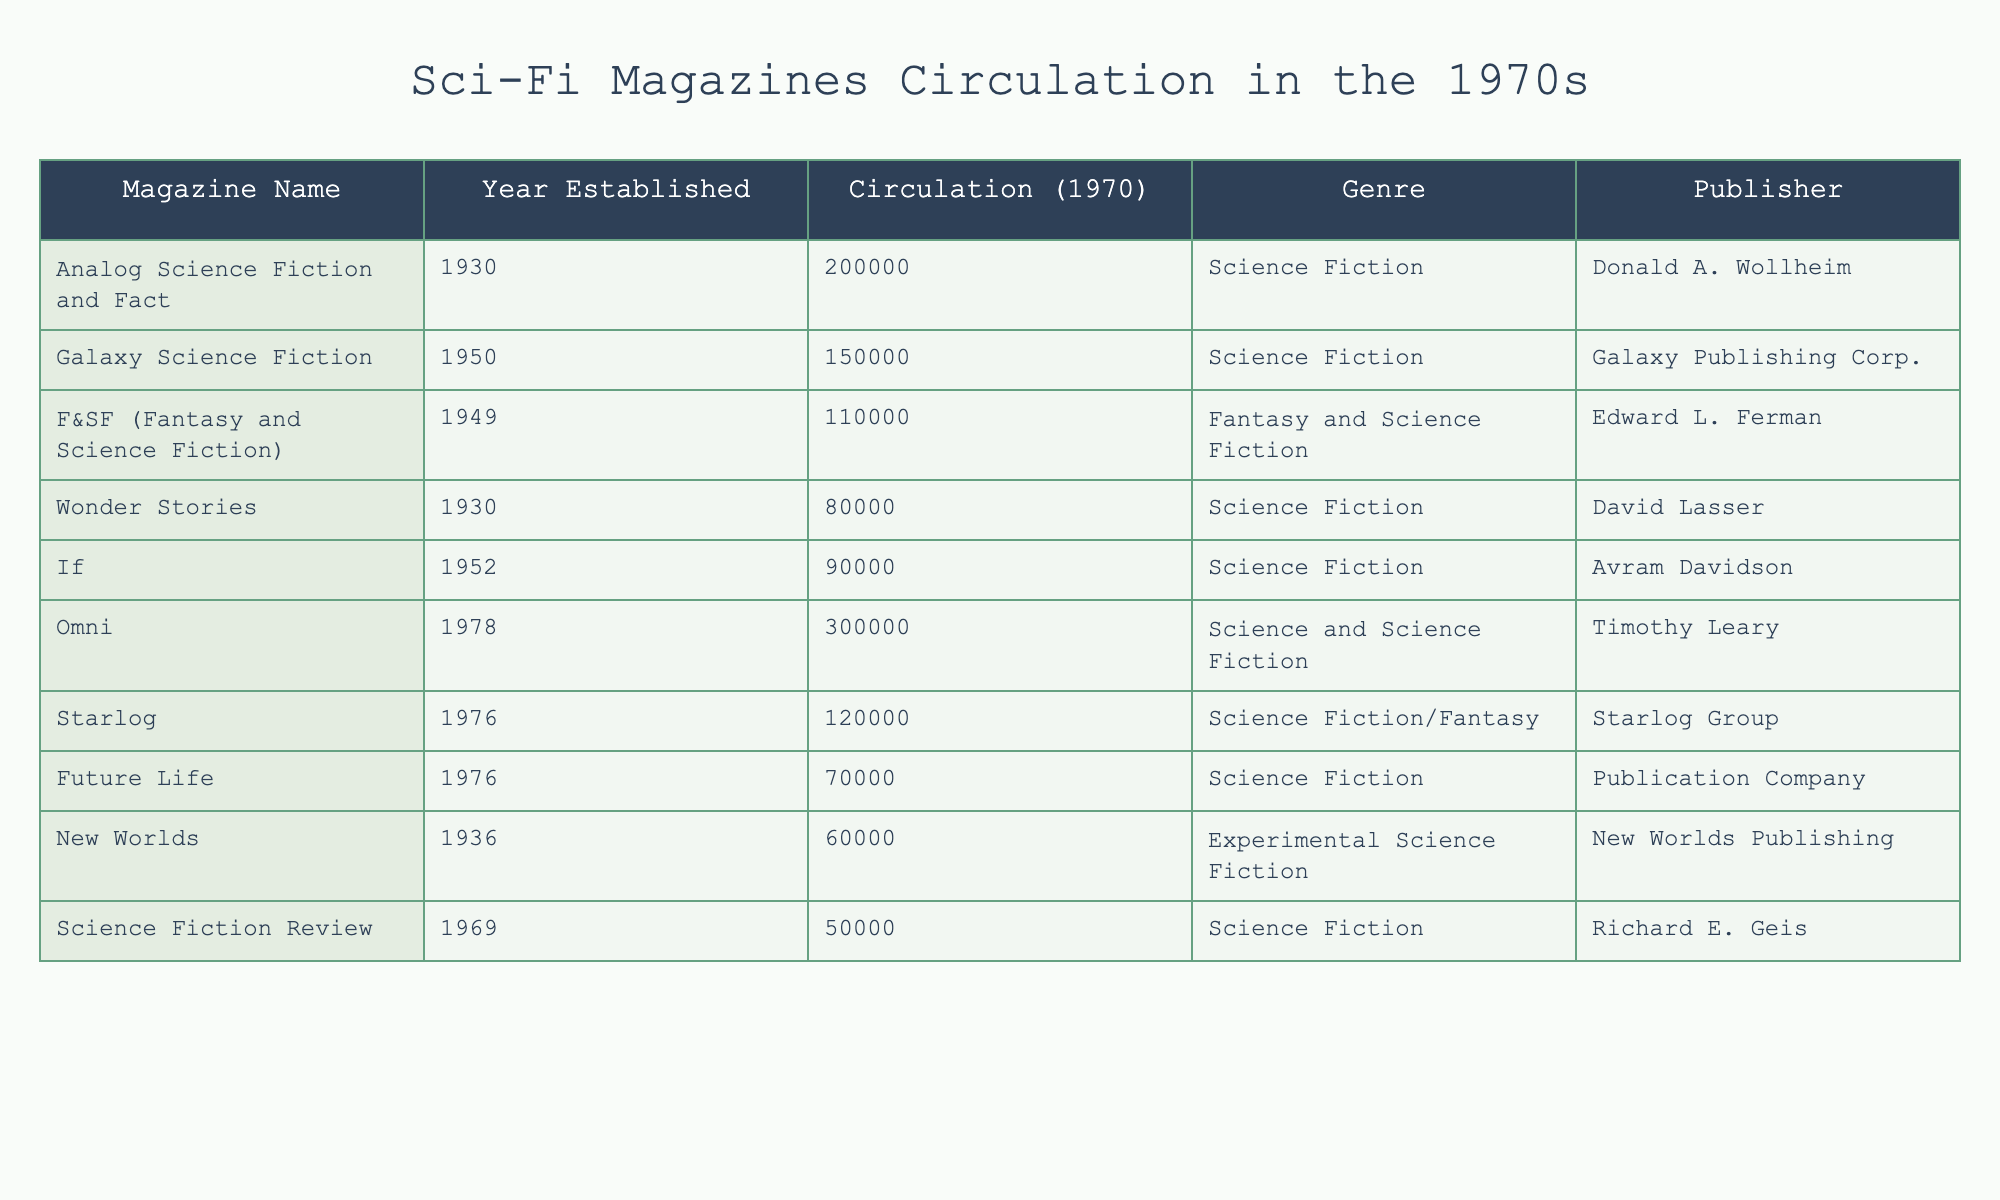What is the circulation of Analog Science Fiction and Fact in 1970? The table shows that the circulation of Analog Science Fiction and Fact in 1970 is 200,000.
Answer: 200000 Which magazine had the lowest circulation in 1970? By examining the circulation numbers, the magazine with the lowest circulation in 1970 is Science Fiction Review, with a circulation of 50,000.
Answer: 50000 What is the total circulation of all the magazines listed in 1970? To find the total circulation, I sum up all the circulation values: 200,000 + 150,000 + 110,000 + 80,000 + 90,000 + 300,000 + 120,000 + 70,000 + 60,000 + 50,000 = 1,080,000.
Answer: 1080000 Is Omni the highest-circulated magazine in 1970? By comparing the circulation numbers, I see that Omni has a circulation of 300,000, which is higher than all the other magazines listed. Therefore, the statement is true.
Answer: Yes How many magazines had a circulation exceeding 100,000 in 1970? Checking the circulation numbers, the magazines that exceed 100,000 are: Analog Science Fiction and Fact (200,000), Galaxy Science Fiction (150,000), F&SF (110,000), and Omni (300,000). That gives us a total of four magazines.
Answer: 4 What is the difference in circulation between Galaxy Science Fiction and F&SF? To find the difference, I subtract the circulation of F&SF (110,000) from Galaxy Science Fiction (150,000): 150,000 - 110,000 = 40,000.
Answer: 40000 Which publisher has the most magazines listed in the table? Analyzing the publishers, the publisher Donald A. Wollheim for Analog Science Fiction and Fact and Edward L. Ferman for F&SF are both unique, but the only other publishers are distinct per magazine. Therefore, each publisher has just one magazine in this list, making none more frequent than the others.
Answer: None Does Future Life have a higher circulation than Wonder Stories? By comparing their circulations, Future Life has 70,000, while Wonder Stories has 80,000. Since 70,000 is less than 80,000, the statement is false.
Answer: No 